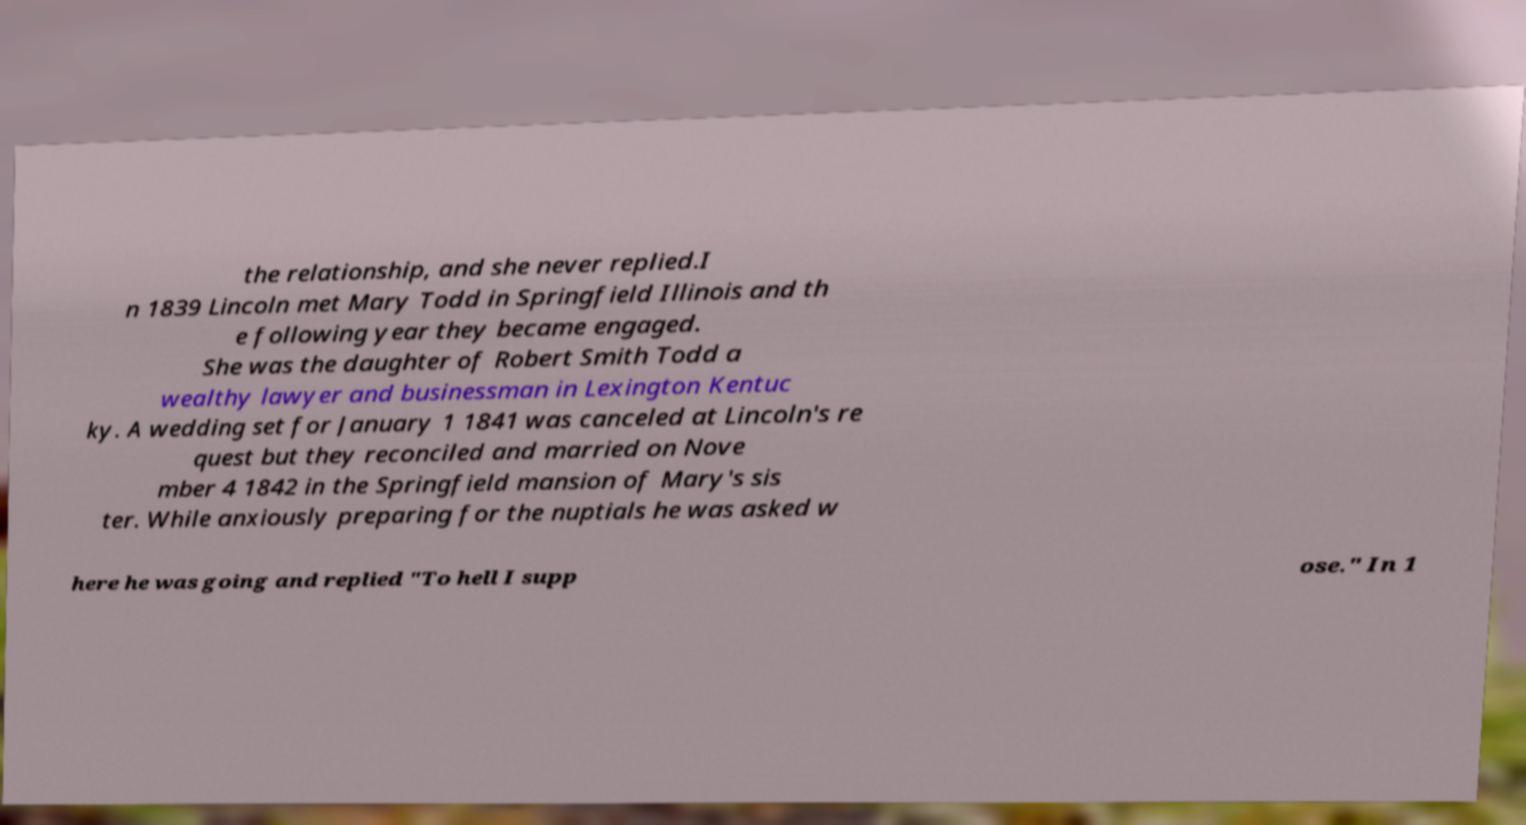What messages or text are displayed in this image? I need them in a readable, typed format. the relationship, and she never replied.I n 1839 Lincoln met Mary Todd in Springfield Illinois and th e following year they became engaged. She was the daughter of Robert Smith Todd a wealthy lawyer and businessman in Lexington Kentuc ky. A wedding set for January 1 1841 was canceled at Lincoln's re quest but they reconciled and married on Nove mber 4 1842 in the Springfield mansion of Mary's sis ter. While anxiously preparing for the nuptials he was asked w here he was going and replied "To hell I supp ose." In 1 